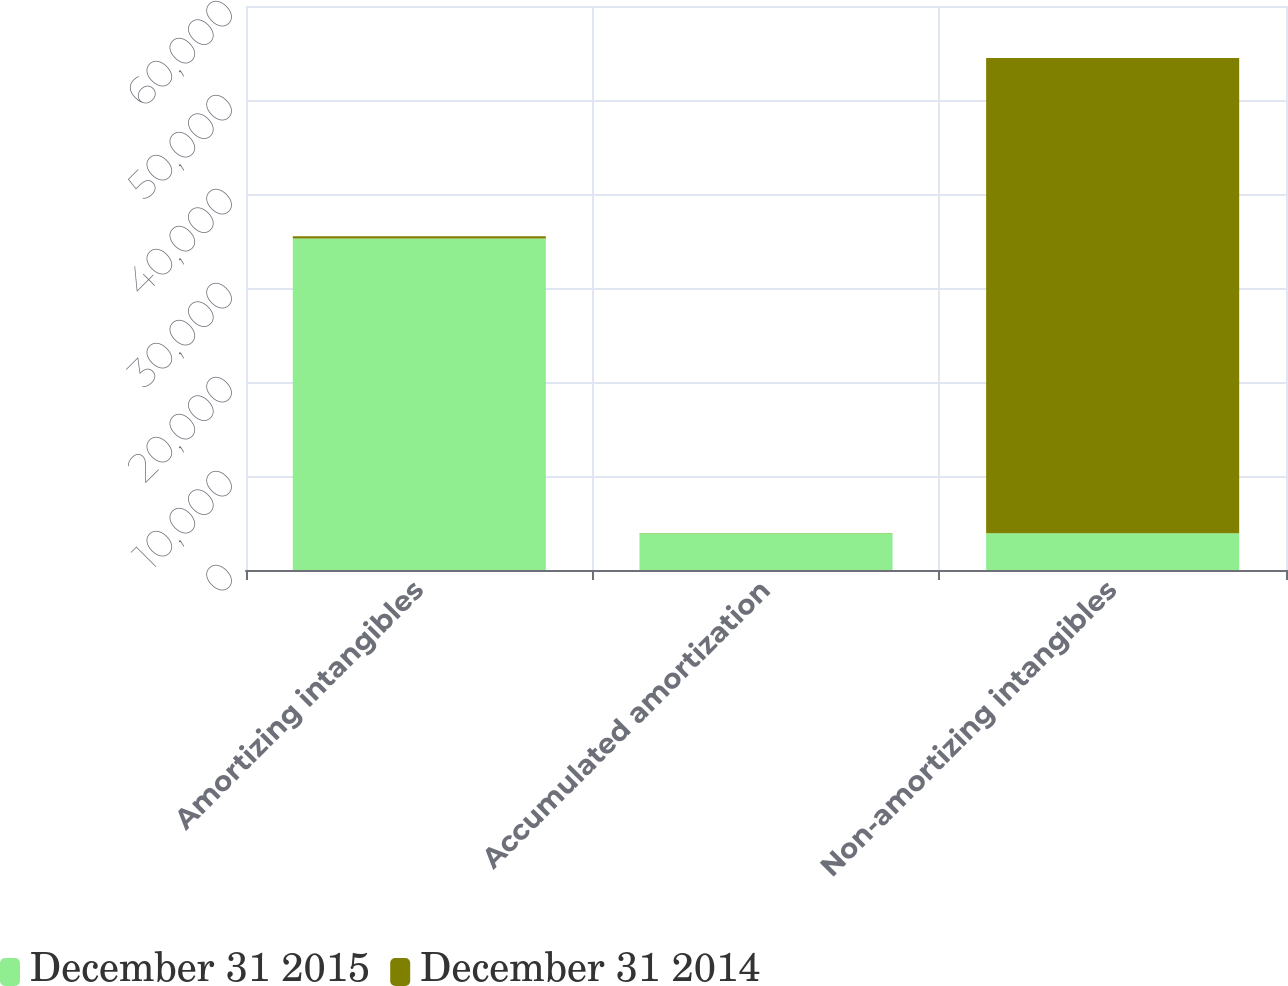<chart> <loc_0><loc_0><loc_500><loc_500><stacked_bar_chart><ecel><fcel>Amortizing intangibles<fcel>Accumulated amortization<fcel>Non-amortizing intangibles<nl><fcel>December 31 2015<fcel>35263<fcel>3899<fcel>3899<nl><fcel>December 31 2014<fcel>233<fcel>50<fcel>50565<nl></chart> 